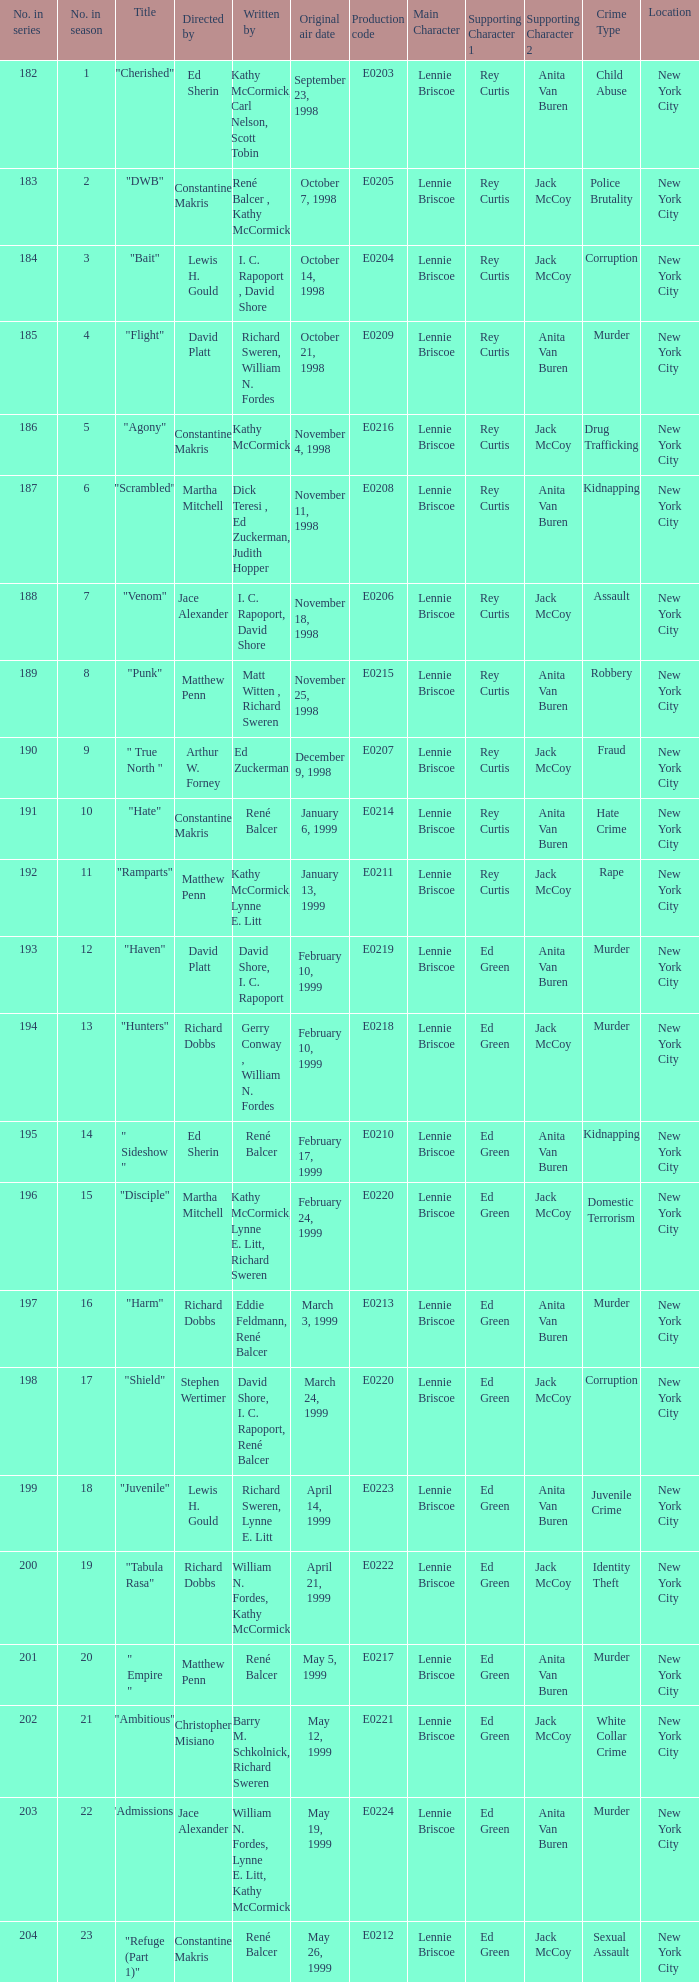The episode with the title "Bait" has what original air date? October 14, 1998. 